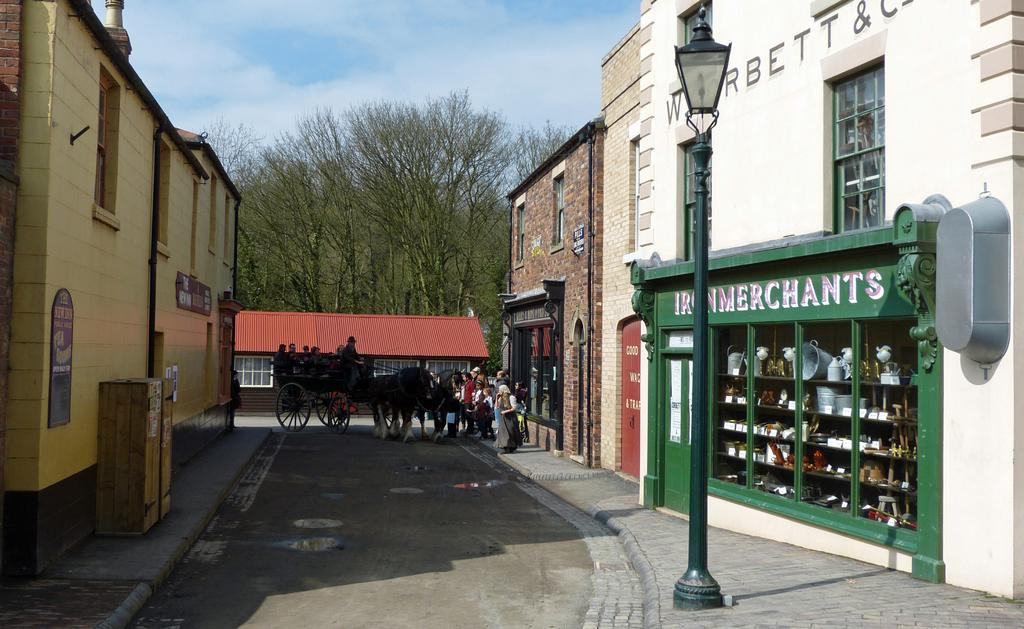<image>
Present a compact description of the photo's key features. PEOPLE LOOKING AT A HORSE DRAWN CARRIAGE IN AN ALLEYWAY CLOSE TO IRON MERCHANTS 